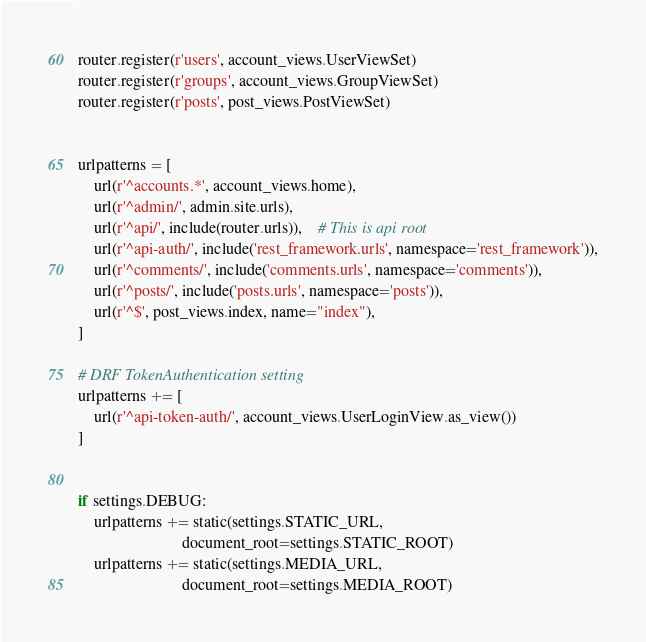Convert code to text. <code><loc_0><loc_0><loc_500><loc_500><_Python_>router.register(r'users', account_views.UserViewSet)
router.register(r'groups', account_views.GroupViewSet)
router.register(r'posts', post_views.PostViewSet)


urlpatterns = [
    url(r'^accounts.*', account_views.home),
    url(r'^admin/', admin.site.urls),
    url(r'^api/', include(router.urls)),    # This is api root
    url(r'^api-auth/', include('rest_framework.urls', namespace='rest_framework')),
    url(r'^comments/', include('comments.urls', namespace='comments')),
    url(r'^posts/', include('posts.urls', namespace='posts')),
    url(r'^$', post_views.index, name="index"),
]

# DRF TokenAuthentication setting
urlpatterns += [
    url(r'^api-token-auth/', account_views.UserLoginView.as_view())
]


if settings.DEBUG:
    urlpatterns += static(settings.STATIC_URL,
                          document_root=settings.STATIC_ROOT)
    urlpatterns += static(settings.MEDIA_URL,
                          document_root=settings.MEDIA_ROOT)
</code> 